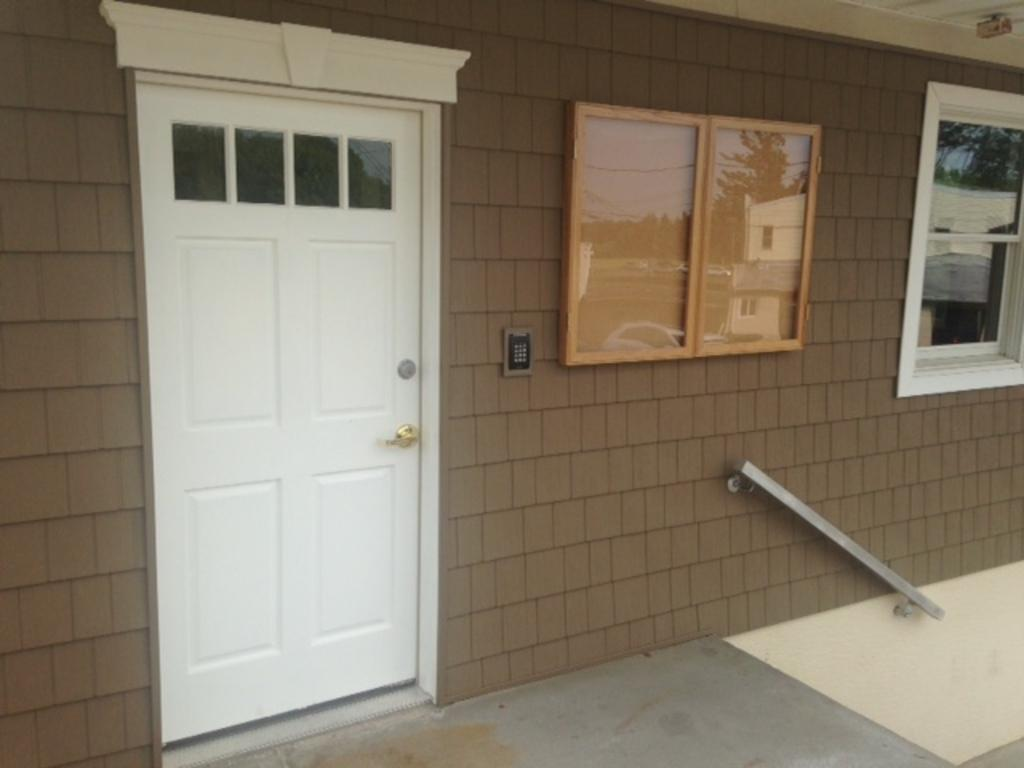What type of structure is depicted in the image? The image is of a house. What can be seen in the foreground of the picture? There is a door, a board, and a window in the foreground of the picture. What material is used for the wall in the image? There is a brick wall in the image. What type of pie is being served on the leg in the image? There is no pie or leg present in the image; it features a house with a door, board, and window in the foreground, and a brick wall. 